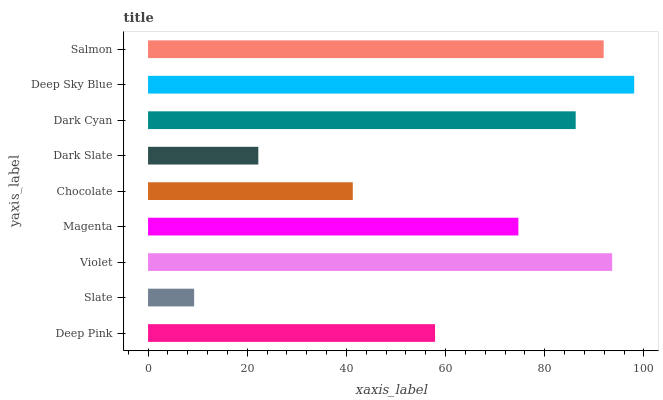Is Slate the minimum?
Answer yes or no. Yes. Is Deep Sky Blue the maximum?
Answer yes or no. Yes. Is Violet the minimum?
Answer yes or no. No. Is Violet the maximum?
Answer yes or no. No. Is Violet greater than Slate?
Answer yes or no. Yes. Is Slate less than Violet?
Answer yes or no. Yes. Is Slate greater than Violet?
Answer yes or no. No. Is Violet less than Slate?
Answer yes or no. No. Is Magenta the high median?
Answer yes or no. Yes. Is Magenta the low median?
Answer yes or no. Yes. Is Salmon the high median?
Answer yes or no. No. Is Chocolate the low median?
Answer yes or no. No. 